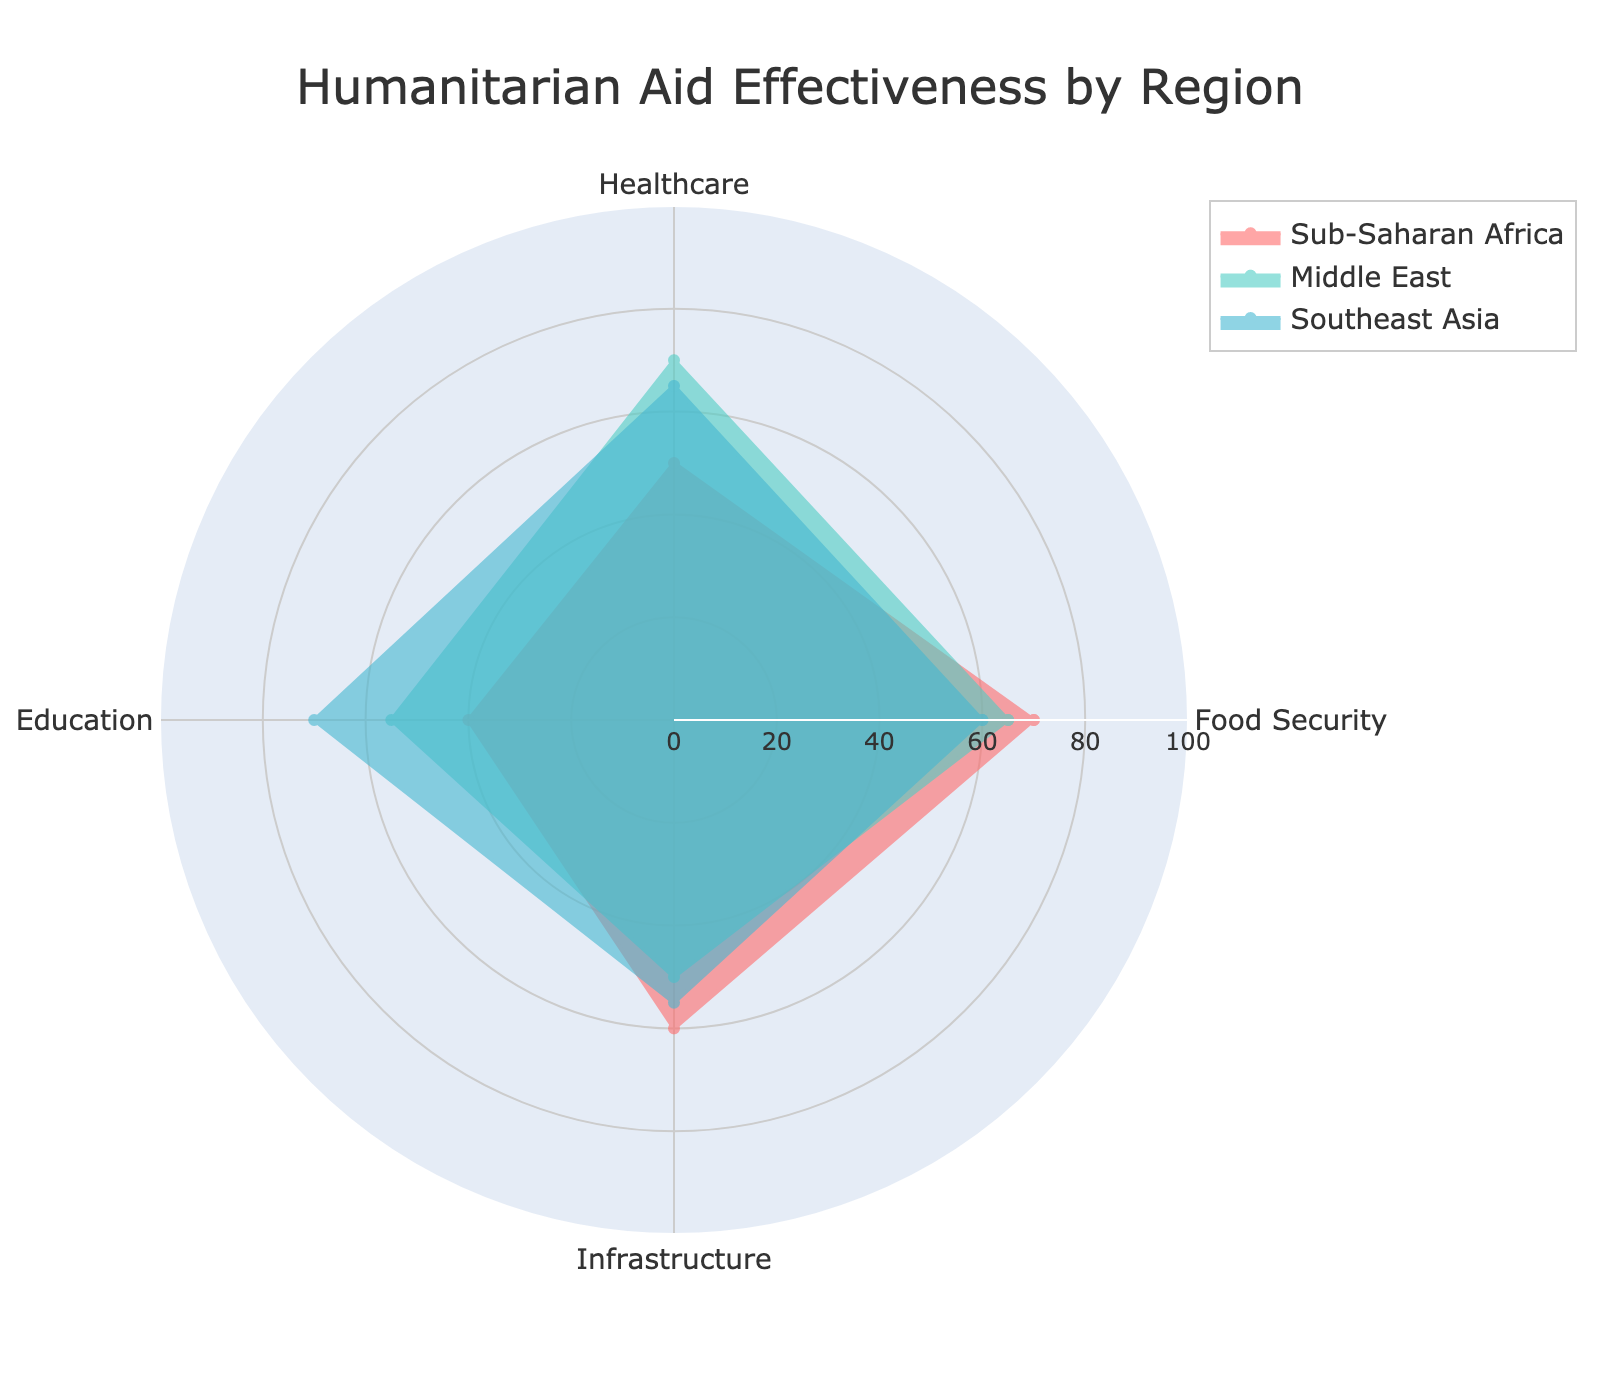What is the title of the radar chart? The title of the radar chart is given at the top of the figure.
Answer: Humanitarian Aid Effectiveness by Region How many categories are being evaluated for humanitarian aid effectiveness? The categories can be counted from the labels on the perimeter of the radar chart.
Answer: 4 Which region has the highest effectiveness in Healthcare? By looking at each region's value for the Healthcare category, the region with the highest value is identified.
Answer: Middle East Which category has the lowest effectiveness for Southeast Asia? By examining the values for Southeast Asia, identify the category with the smallest value.
Answer: Food Security What is the average effectiveness score across all regions for Infrastructure? Sum the Infrastructure values for all regions (60 for Sub-Saharan Africa, 50 for Middle East, 55 for Southeast Asia) and divide by the number of regions (3).
Answer: (60 + 50 + 55) / 3 = 55 Which category shows the greatest range of effectiveness values across all regions? Calculate the range for each category by subtracting the minimum value from the maximum value. Compare the ranges to identify the greatest one.
Answer: Healthcare (70 - 50 = 20) How does the Food Security effectiveness in Sub-Saharan Africa compare to Southeast Asia? Compare the Food Security value for Sub-Saharan Africa (70) with that of Southeast Asia (60).
Answer: Sub-Saharan Africa has higher Food Security effectiveness What is the total effectiveness score for Education in all three regions combined? Sum the Education values for all regions (40 for Sub-Saharan Africa, 55 for Middle East, 70 for Southeast Asia).
Answer: 40 + 55 + 70 = 165 Which region shows the most balanced effectiveness across all categories? Look for the region whose values across categories are closest to each other, typically by noting the smallest range within that region's values.
Answer: Middle East (values: 65, 70, 55, 50) What is the difference in effectiveness between Food Security and Education in the Middle East? Subtract the Education value (55) from the Food Security value (65) for the Middle East.
Answer: 65 - 55 = 10 